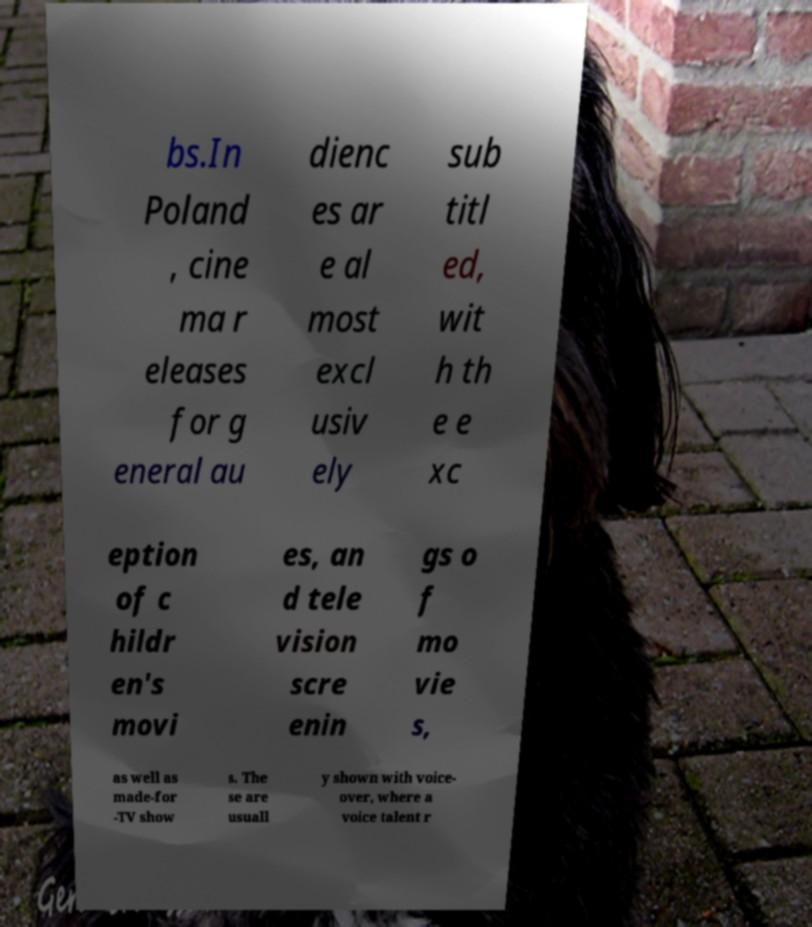Can you read and provide the text displayed in the image?This photo seems to have some interesting text. Can you extract and type it out for me? bs.In Poland , cine ma r eleases for g eneral au dienc es ar e al most excl usiv ely sub titl ed, wit h th e e xc eption of c hildr en's movi es, an d tele vision scre enin gs o f mo vie s, as well as made-for -TV show s. The se are usuall y shown with voice- over, where a voice talent r 